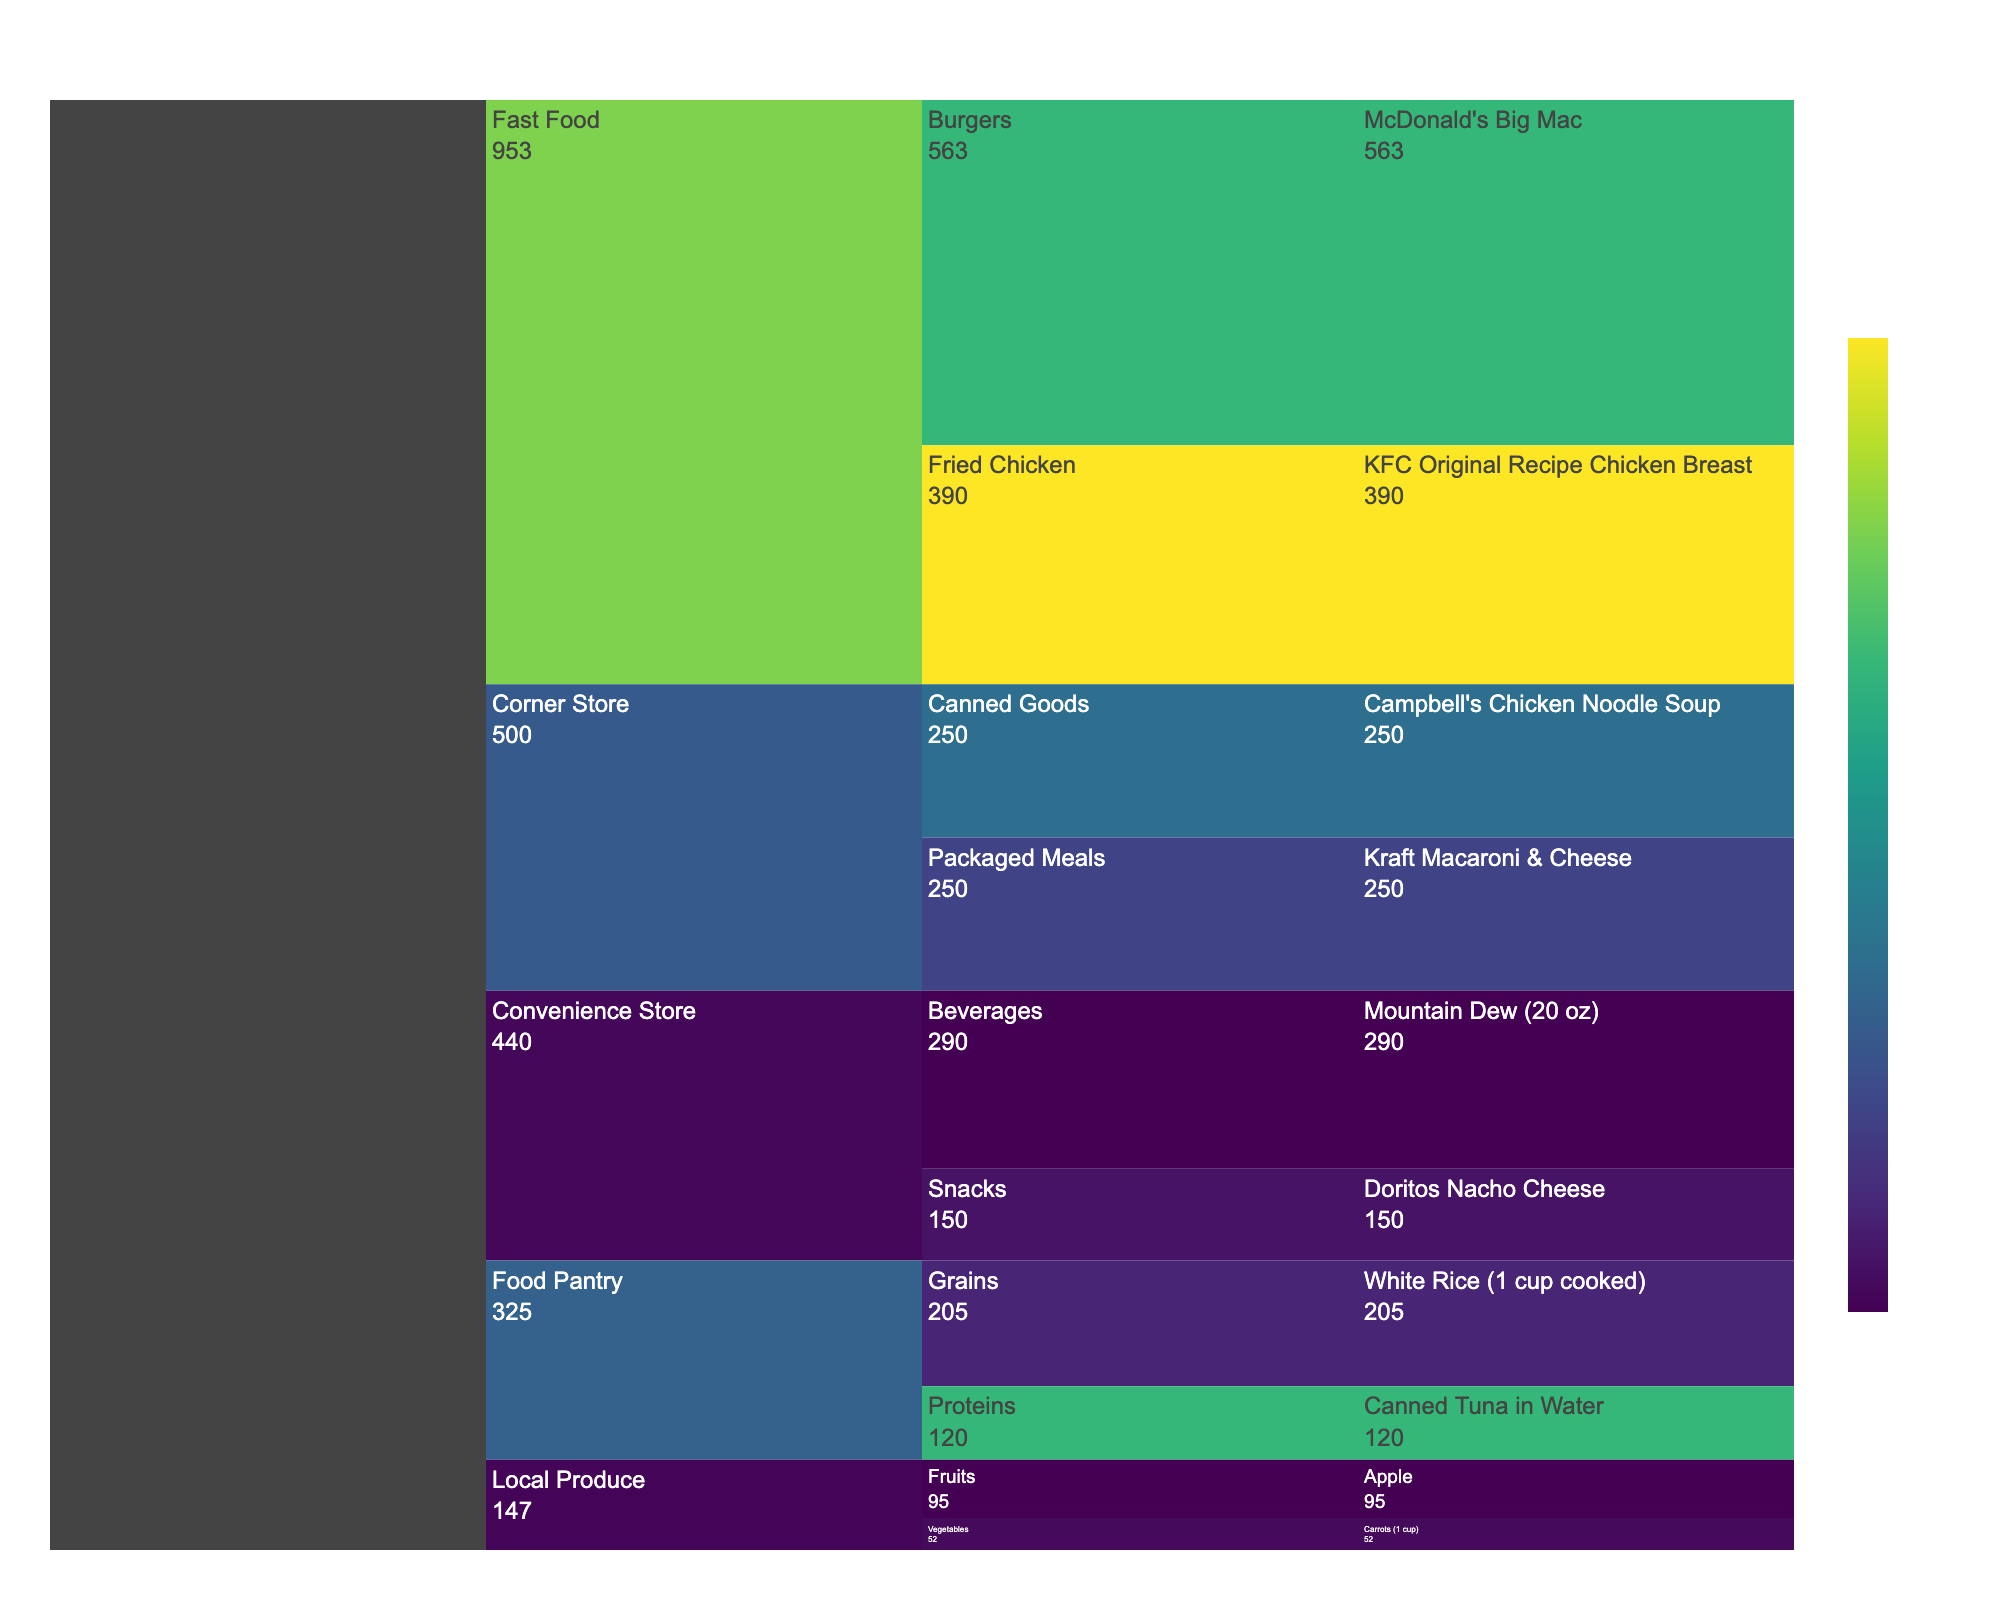What is the title of the Icicle Chart? Look at the top part of the figure where the main heading is usually displayed.
Answer: Nutritional Value Analysis of Common Food Items in Underserved Neighborhoods Which food item has the highest protein content in the 'Fast Food' category? Identify the 'Fast Food' category, then look at the subcategories and food items and check the color representing protein content. The darkest color will indicate the highest protein.
Answer: KFC Original Recipe Chicken Breast How many calories does the 'McDonald's Big Mac' have? Find the 'McDonald's Big Mac' under the 'Burgers' subcategory of 'Fast Food' and read the calorie count displayed.
Answer: 563 Which subcategory within 'Convenience Store' has higher total calories, 'Snacks' or 'Beverages'? Sum the calorie values of food items under 'Snacks' and 'Beverages' in the 'Convenience Store' category, then compare.
Answer: Beverages Between 'Campbell's Chicken Noodle Soup' and 'Kraft Macaroni & Cheese,' which has more calories? Locate both items in the 'Canned Goods' and 'Packaged Meals' subcategories of 'Corner Store' and compare their calorie values.
Answer: Both have the same calories What's the average protein content in the 'Food Pantry' category? Identify all food items in the 'Food Pantry' category, sum their protein contents, and divide by the number of items. (White Rice and Canned Tuna in Water)
Answer: 15 g Does the 'Local Produce' category have any items with a vitamin A content over 400% DV? Inspect the nutrient details of food items under the 'Local Produce' category and check for Vitamin A content over 400%.
Answer: Yes, Carrots Which has fewer carbs, 'Doritos Nacho Cheese' or 'Mountain Dew (20 oz)'? Locate both items under the 'Snacks' and 'Beverages' subcategories of 'Convenience Store' and compare their carbohydrate content.
Answer: Doritos Nacho Cheese Which food item in the figure has the lowest fiber content? Check all food items' fiber content and identify the one with the lowest value.
Answer: Mountain Dew (20 oz) In the 'Food Pantry' category, do grains or proteins have more calories on average? Find the calorie values for grains (White Rice) and proteins (Canned Tuna) under the 'Food Pantry' category, then calculate the average for each and compare.
Answer: Grains 